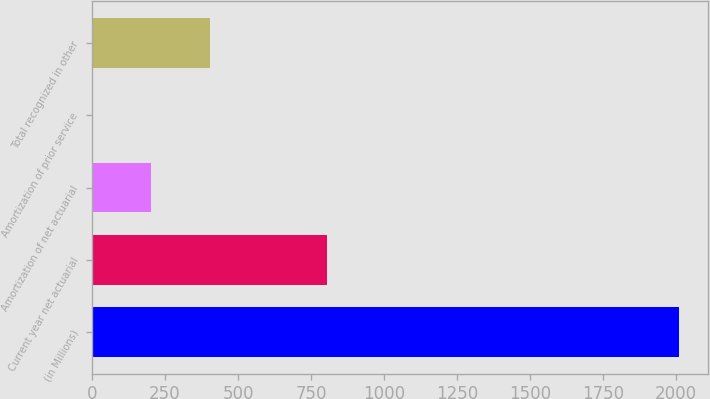<chart> <loc_0><loc_0><loc_500><loc_500><bar_chart><fcel>(in Millions)<fcel>Current year net actuarial<fcel>Amortization of net actuarial<fcel>Amortization of prior service<fcel>Total recognized in other<nl><fcel>2009<fcel>804.14<fcel>201.71<fcel>0.9<fcel>402.52<nl></chart> 